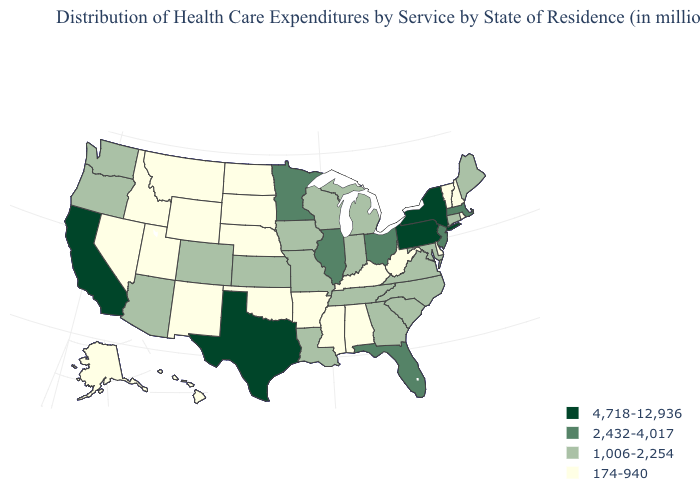What is the value of South Carolina?
Concise answer only. 1,006-2,254. What is the value of Louisiana?
Short answer required. 1,006-2,254. Which states have the lowest value in the USA?
Answer briefly. Alabama, Alaska, Arkansas, Delaware, Hawaii, Idaho, Kentucky, Mississippi, Montana, Nebraska, Nevada, New Hampshire, New Mexico, North Dakota, Oklahoma, Rhode Island, South Dakota, Utah, Vermont, West Virginia, Wyoming. What is the highest value in the MidWest ?
Write a very short answer. 2,432-4,017. What is the lowest value in the South?
Answer briefly. 174-940. What is the value of Florida?
Quick response, please. 2,432-4,017. Among the states that border Arkansas , does Texas have the highest value?
Concise answer only. Yes. Is the legend a continuous bar?
Write a very short answer. No. Does Wyoming have the lowest value in the USA?
Keep it brief. Yes. Does the map have missing data?
Quick response, please. No. What is the value of Oregon?
Answer briefly. 1,006-2,254. Which states have the lowest value in the USA?
Be succinct. Alabama, Alaska, Arkansas, Delaware, Hawaii, Idaho, Kentucky, Mississippi, Montana, Nebraska, Nevada, New Hampshire, New Mexico, North Dakota, Oklahoma, Rhode Island, South Dakota, Utah, Vermont, West Virginia, Wyoming. What is the value of Idaho?
Quick response, please. 174-940. Name the states that have a value in the range 4,718-12,936?
Keep it brief. California, New York, Pennsylvania, Texas. What is the lowest value in states that border Minnesota?
Give a very brief answer. 174-940. 